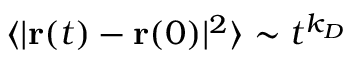Convert formula to latex. <formula><loc_0><loc_0><loc_500><loc_500>\langle | { r } ( t ) - { r } ( 0 ) | ^ { 2 } \rangle \sim t ^ { k _ { D } }</formula> 